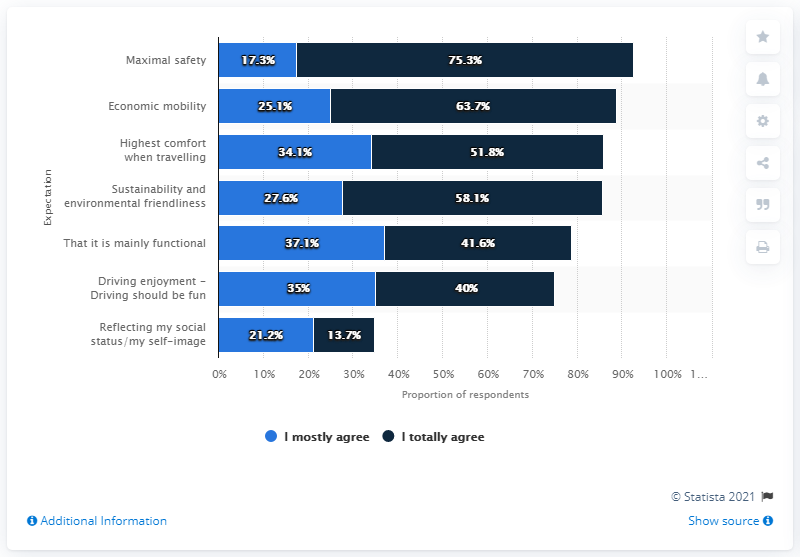Indicate a few pertinent items in this graphic. According to the survey, 75.3% of respondents believe that cars of the future should prioritize safety. The combined percentage of the responses for maximal safety is 92.6%. The least popular response that most people agreed with was 'maximal safety.' 